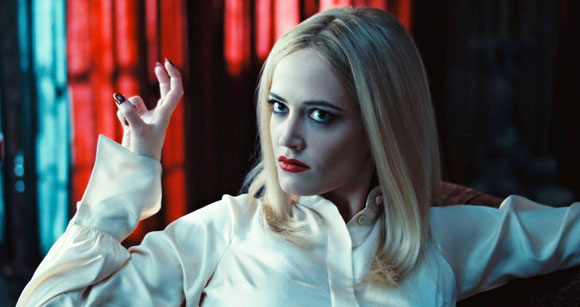Can you describe how color plays a role in this image? Color is a significant element in this image, creating a vivid contrast and setting the mood. The deep reds of the couch and background suggest a passionate or intense theme, while the pure white of the blouse introduces purity or innocence. This juxtaposition may be reflective of the character's internal conflicts or the overarching themes of the story. The use of red also draws the viewer’s attention directly to the central figure, emphasizing her importance and the emotional weight she carries. 